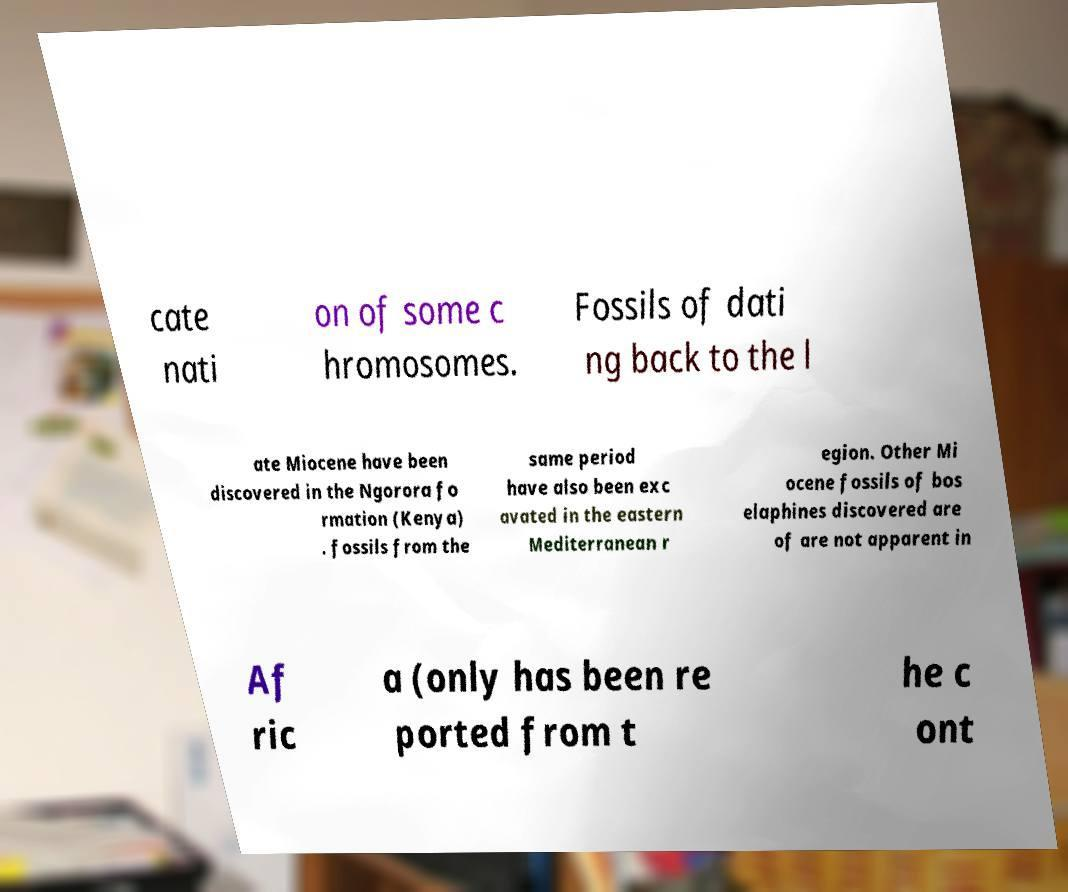Could you extract and type out the text from this image? cate nati on of some c hromosomes. Fossils of dati ng back to the l ate Miocene have been discovered in the Ngorora fo rmation (Kenya) . fossils from the same period have also been exc avated in the eastern Mediterranean r egion. Other Mi ocene fossils of bos elaphines discovered are of are not apparent in Af ric a (only has been re ported from t he c ont 